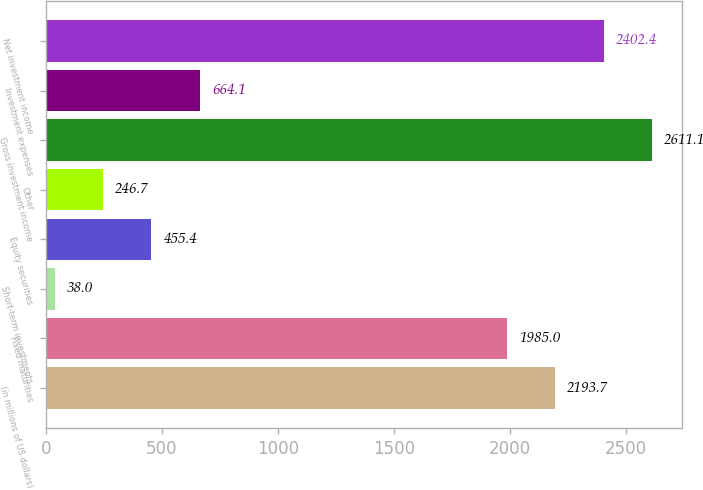<chart> <loc_0><loc_0><loc_500><loc_500><bar_chart><fcel>(in millions of US dollars)<fcel>Fixed maturities<fcel>Short-term investments<fcel>Equity securities<fcel>Other<fcel>Gross investment income<fcel>Investment expenses<fcel>Net investment income<nl><fcel>2193.7<fcel>1985<fcel>38<fcel>455.4<fcel>246.7<fcel>2611.1<fcel>664.1<fcel>2402.4<nl></chart> 